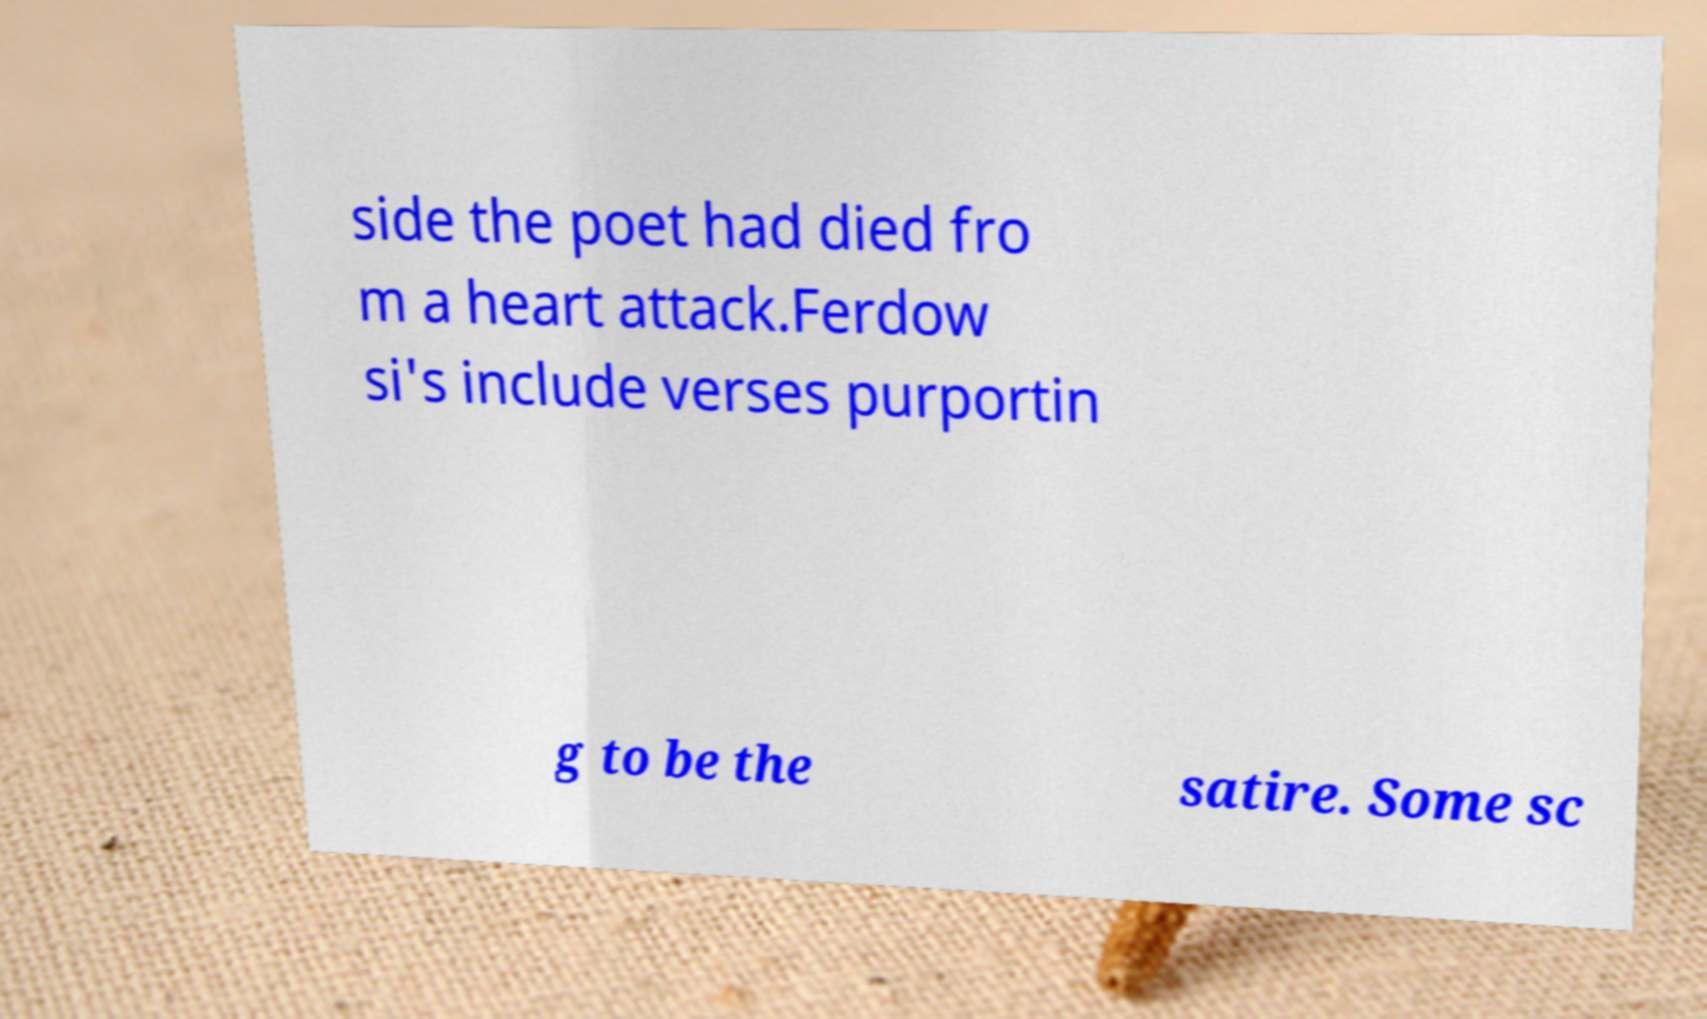Can you accurately transcribe the text from the provided image for me? side the poet had died fro m a heart attack.Ferdow si's include verses purportin g to be the satire. Some sc 